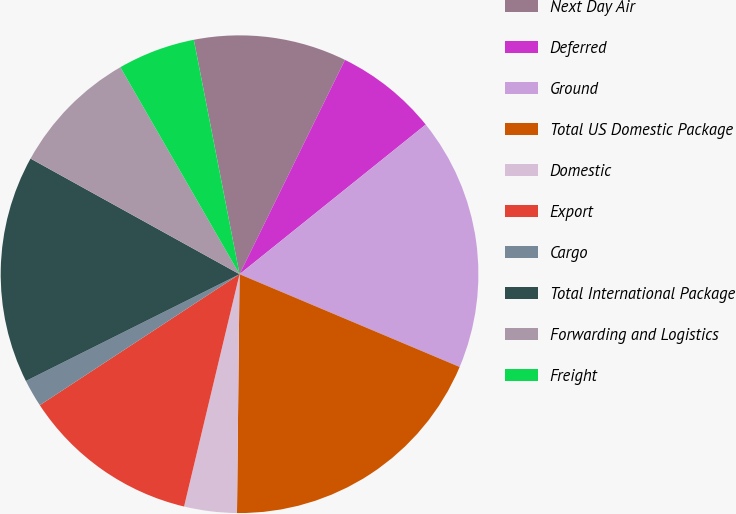<chart> <loc_0><loc_0><loc_500><loc_500><pie_chart><fcel>Next Day Air<fcel>Deferred<fcel>Ground<fcel>Total US Domestic Package<fcel>Domestic<fcel>Export<fcel>Cargo<fcel>Total International Package<fcel>Forwarding and Logistics<fcel>Freight<nl><fcel>10.34%<fcel>6.95%<fcel>17.12%<fcel>18.82%<fcel>3.56%<fcel>12.03%<fcel>1.86%<fcel>15.42%<fcel>8.64%<fcel>5.25%<nl></chart> 